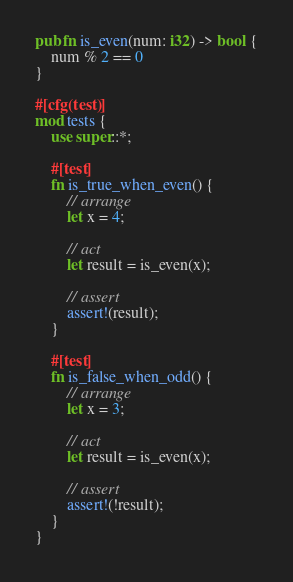Convert code to text. <code><loc_0><loc_0><loc_500><loc_500><_Rust_>pub fn is_even(num: i32) -> bool {
    num % 2 == 0
}

#[cfg(test)]
mod tests {
    use super::*;

    #[test]
    fn is_true_when_even() {
        // arrange
        let x = 4;

        // act
        let result = is_even(x);

        // assert
        assert!(result);
    }

    #[test]
    fn is_false_when_odd() {
        // arrange
        let x = 3;

        // act
        let result = is_even(x);

        // assert
        assert!(!result);
    }
}
</code> 